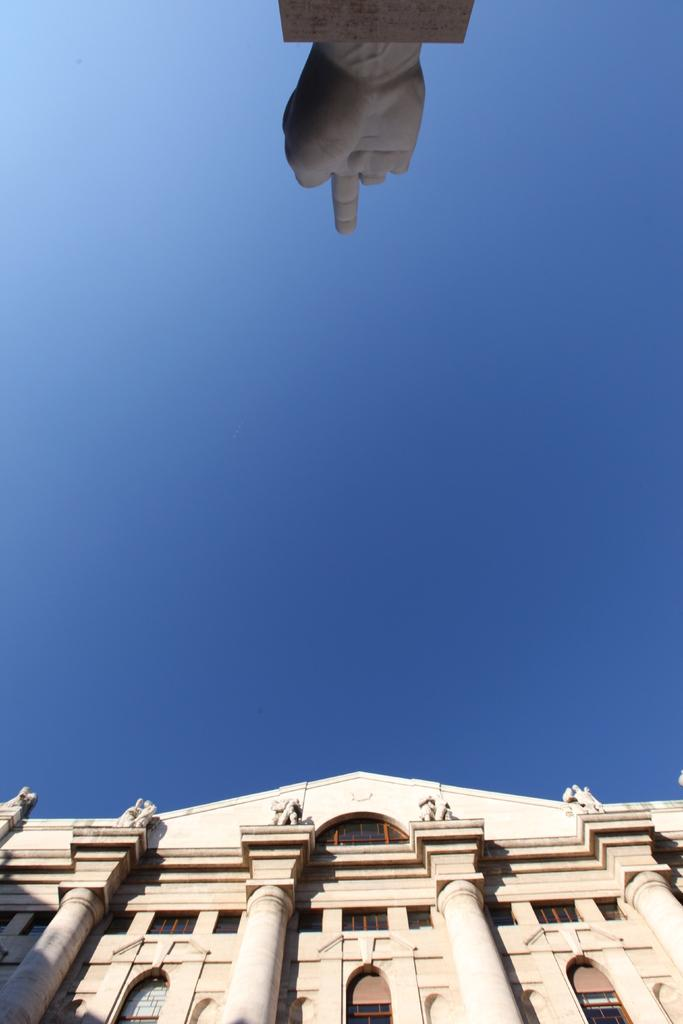What type of structure is visible in the image? There is a building in the image. Can you describe any unique features of the building? There is a structure resembling a hand at the top of the image. What type of thunder can be heard coming from the building in the image? There is no thunder present in the image, as it is a still image and does not contain any sounds. 